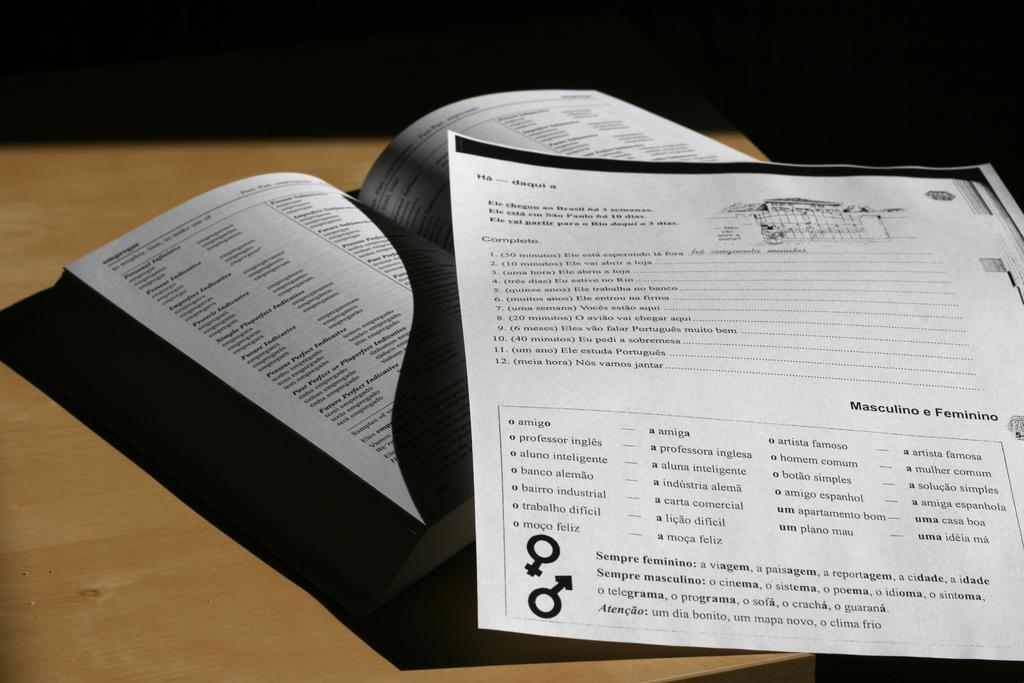<image>
Provide a brief description of the given image. A box with text that has o amigo at the first line. 